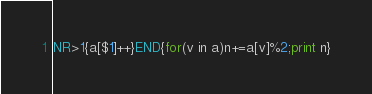<code> <loc_0><loc_0><loc_500><loc_500><_Awk_>NR>1{a[$1]++}END{for(v in a)n+=a[v]%2;print n}</code> 